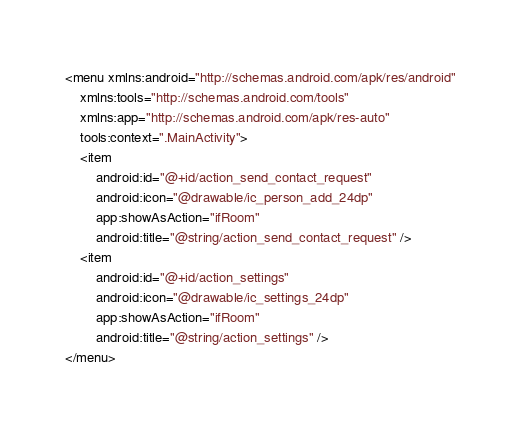Convert code to text. <code><loc_0><loc_0><loc_500><loc_500><_XML_><menu xmlns:android="http://schemas.android.com/apk/res/android"
    xmlns:tools="http://schemas.android.com/tools"
    xmlns:app="http://schemas.android.com/apk/res-auto"
    tools:context=".MainActivity">
    <item
        android:id="@+id/action_send_contact_request"
        android:icon="@drawable/ic_person_add_24dp"
        app:showAsAction="ifRoom"
        android:title="@string/action_send_contact_request" />
    <item
        android:id="@+id/action_settings"
        android:icon="@drawable/ic_settings_24dp"
        app:showAsAction="ifRoom"
        android:title="@string/action_settings" />
</menu>
</code> 